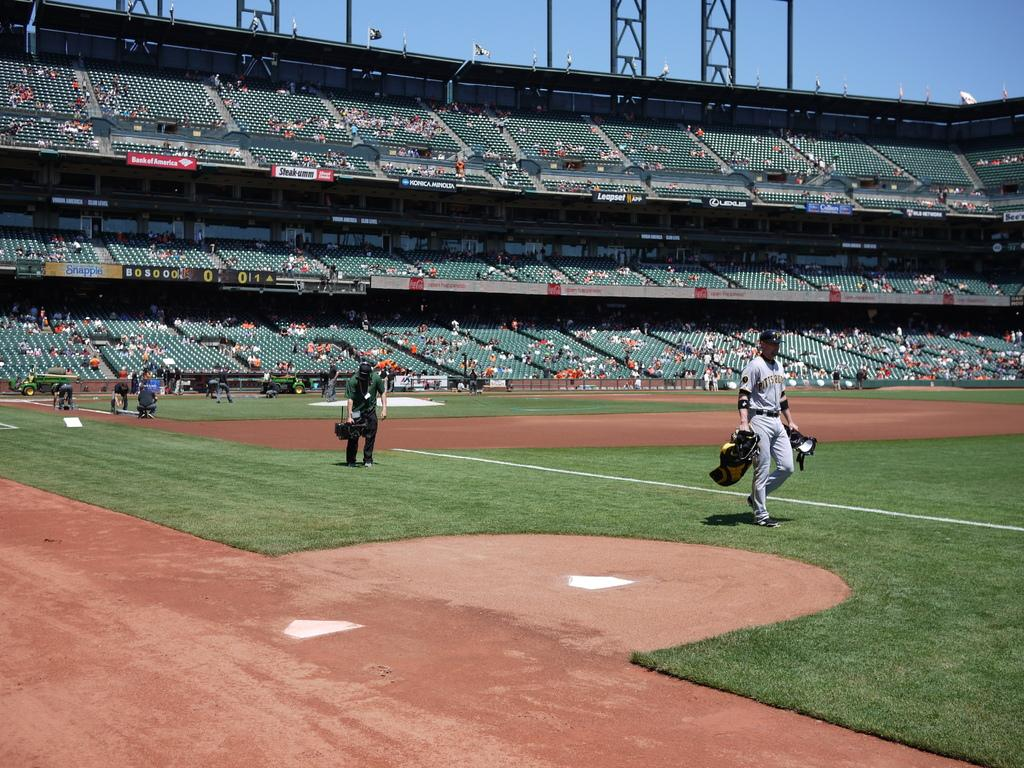What type of surface is visible in the image? There is a grass lawn in the image. How many people are present in the image? There are many people in the image. What are some people holding in their hands? Some people are holding something in their hands. What can be seen in the background of the image? There is a stadium and stands visible in the background of the image, as well as the sky. What type of sweater is being worn by the person in the circle in the image? There is no circle or person wearing a sweater present in the image. 